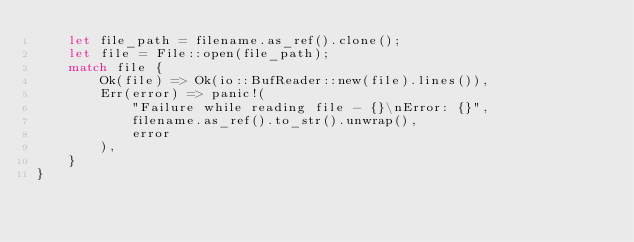Convert code to text. <code><loc_0><loc_0><loc_500><loc_500><_Rust_>    let file_path = filename.as_ref().clone();
    let file = File::open(file_path);
    match file {
        Ok(file) => Ok(io::BufReader::new(file).lines()),
        Err(error) => panic!(
            "Failure while reading file - {}\nError: {}",
            filename.as_ref().to_str().unwrap(),
            error
        ),
    }
}
</code> 